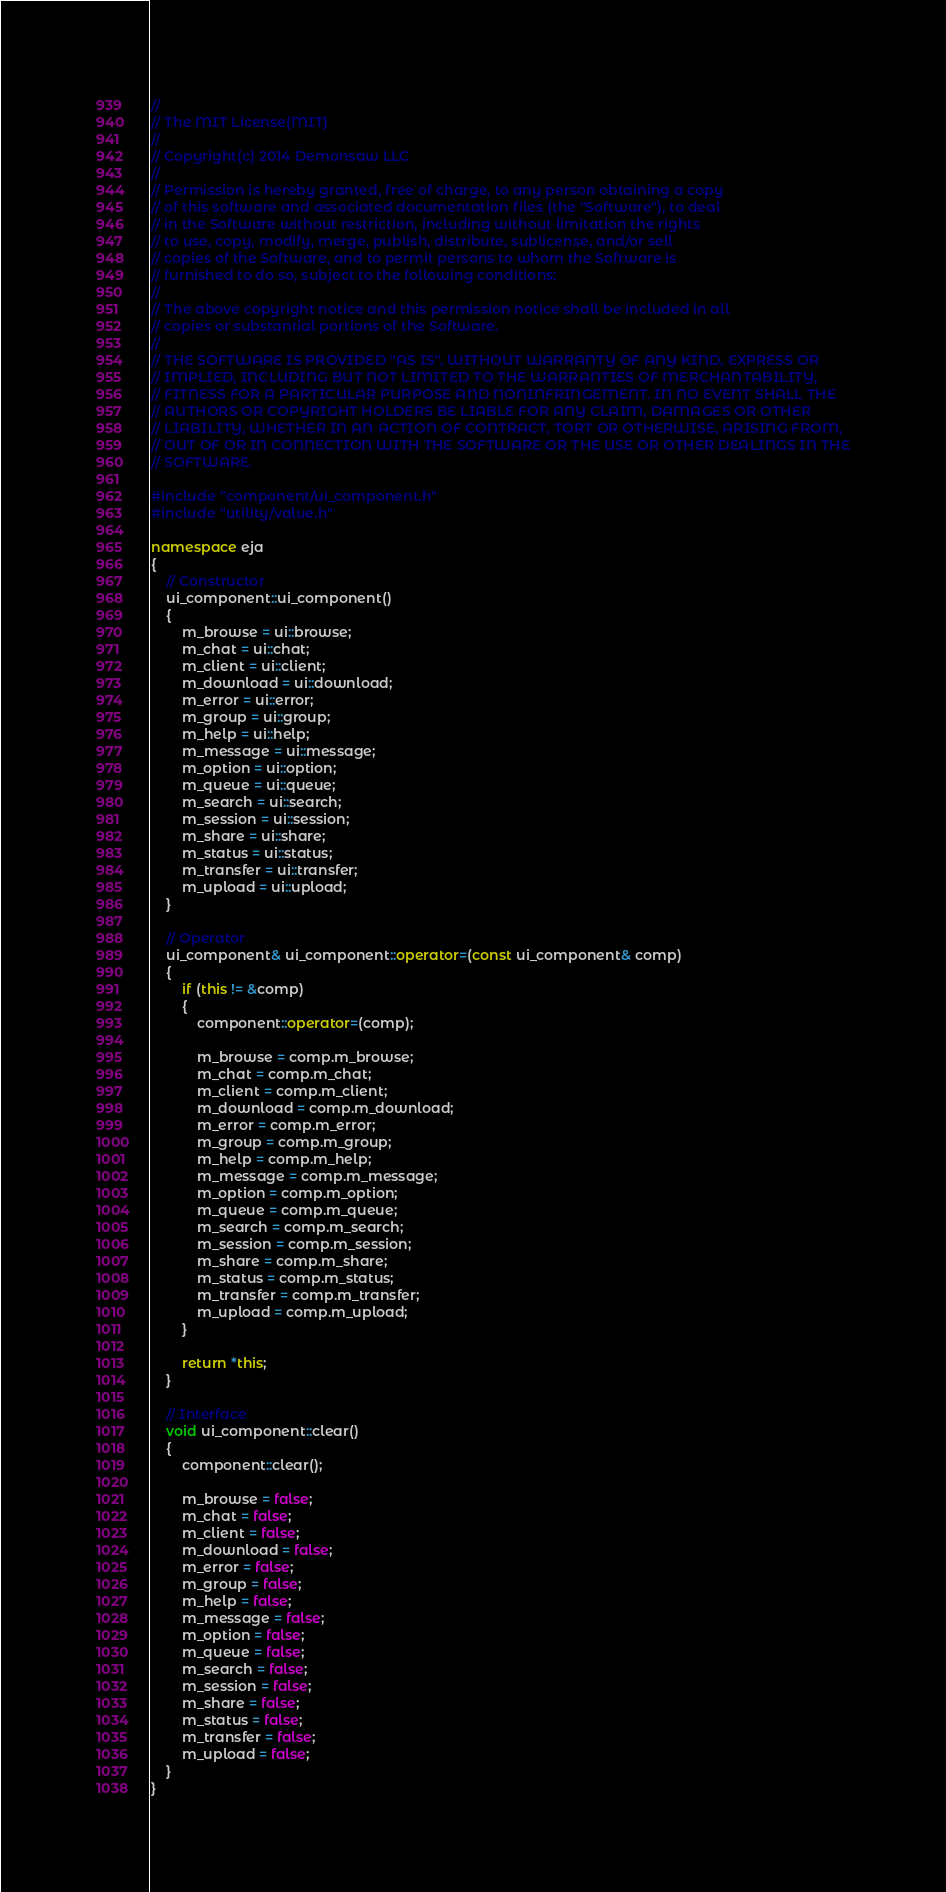Convert code to text. <code><loc_0><loc_0><loc_500><loc_500><_C++_>//
// The MIT License(MIT)
//
// Copyright(c) 2014 Demonsaw LLC
//
// Permission is hereby granted, free of charge, to any person obtaining a copy
// of this software and associated documentation files (the "Software"), to deal
// in the Software without restriction, including without limitation the rights
// to use, copy, modify, merge, publish, distribute, sublicense, and/or sell
// copies of the Software, and to permit persons to whom the Software is
// furnished to do so, subject to the following conditions:
// 
// The above copyright notice and this permission notice shall be included in all
// copies or substantial portions of the Software.
// 
// THE SOFTWARE IS PROVIDED "AS IS", WITHOUT WARRANTY OF ANY KIND, EXPRESS OR
// IMPLIED, INCLUDING BUT NOT LIMITED TO THE WARRANTIES OF MERCHANTABILITY,
// FITNESS FOR A PARTICULAR PURPOSE AND NONINFRINGEMENT. IN NO EVENT SHALL THE
// AUTHORS OR COPYRIGHT HOLDERS BE LIABLE FOR ANY CLAIM, DAMAGES OR OTHER
// LIABILITY, WHETHER IN AN ACTION OF CONTRACT, TORT OR OTHERWISE, ARISING FROM,
// OUT OF OR IN CONNECTION WITH THE SOFTWARE OR THE USE OR OTHER DEALINGS IN THE
// SOFTWARE.

#include "component/ui_component.h"
#include "utility/value.h"

namespace eja
{
	// Constructor
	ui_component::ui_component()
	{
		m_browse = ui::browse;
		m_chat = ui::chat;
		m_client = ui::client;
		m_download = ui::download; 
		m_error = ui::error;
		m_group = ui::group;
		m_help = ui::help;
		m_message = ui::message;
		m_option = ui::option;
		m_queue = ui::queue;
		m_search = ui::search;
		m_session = ui::session;
		m_share = ui::share;
		m_status = ui::status;
		m_transfer = ui::transfer;
		m_upload = ui::upload;
	}

	// Operator
	ui_component& ui_component::operator=(const ui_component& comp)
	{
		if (this != &comp)
		{
			component::operator=(comp);

			m_browse = comp.m_browse;
			m_chat = comp.m_chat;
			m_client = comp.m_client;
			m_download = comp.m_download; 
			m_error = comp.m_error;
			m_group = comp.m_group;
			m_help = comp.m_help;
			m_message = comp.m_message;
			m_option = comp.m_option;
			m_queue = comp.m_queue;
			m_search = comp.m_search;
			m_session = comp.m_session;
			m_share = comp.m_share;
			m_status = comp.m_status;
			m_transfer = comp.m_transfer;
			m_upload = comp.m_upload;
		}

		return *this;
	}

	// Interface
	void ui_component::clear()
	{
		component::clear();
		
		m_browse = false;
		m_chat = false;
		m_client = false;		
		m_download = false; 
		m_error = false;
		m_group = false;
		m_help = false;
		m_message = false;
		m_option = false;
		m_queue = false;
		m_search = false;
		m_session = false;
		m_share = false;
		m_status = false;
		m_transfer = false;
		m_upload = false;
	}
}
</code> 